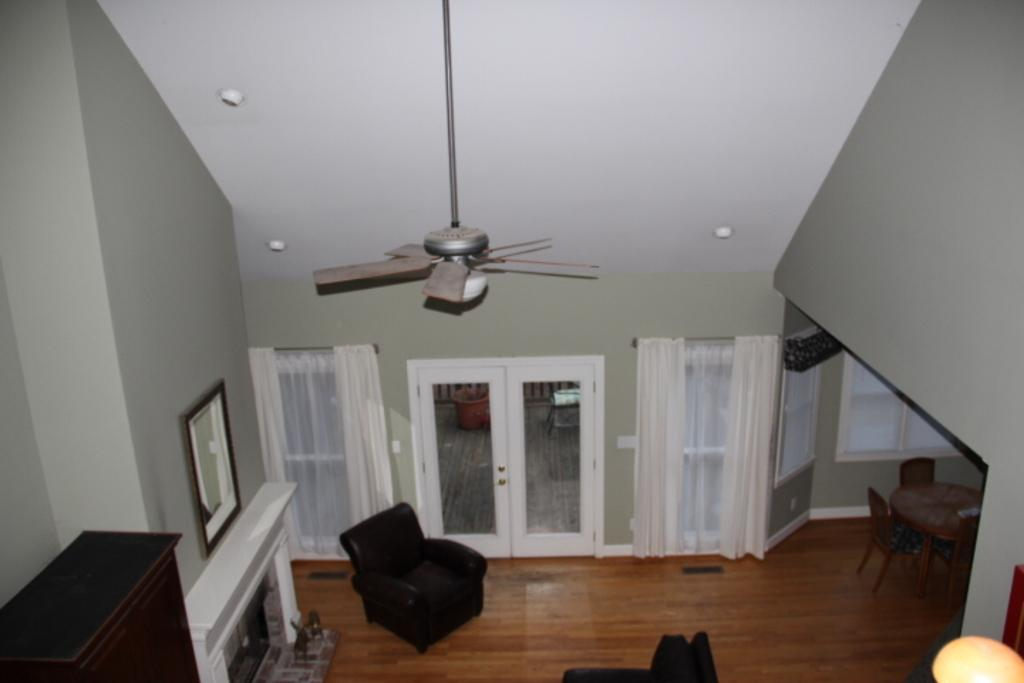What can be seen hanging in the room? There is a fan hanging in the room. How can one enter the room? There is a door to access the room. What is present on the window? There are curtains on the window. What type of furniture is in the room? There is a dining table in the room. Where is the dining table located? The dining table is located in one corner of the room. What other piece of furniture is mentioned in the facts? There is a wardrobe placed on the other side of the wall. What type of thunder can be heard coming from the wardrobe in the image? There is no thunder present in the image, nor is there any indication of sound. What type of rail is visible in the image? There is no rail present in the image. 